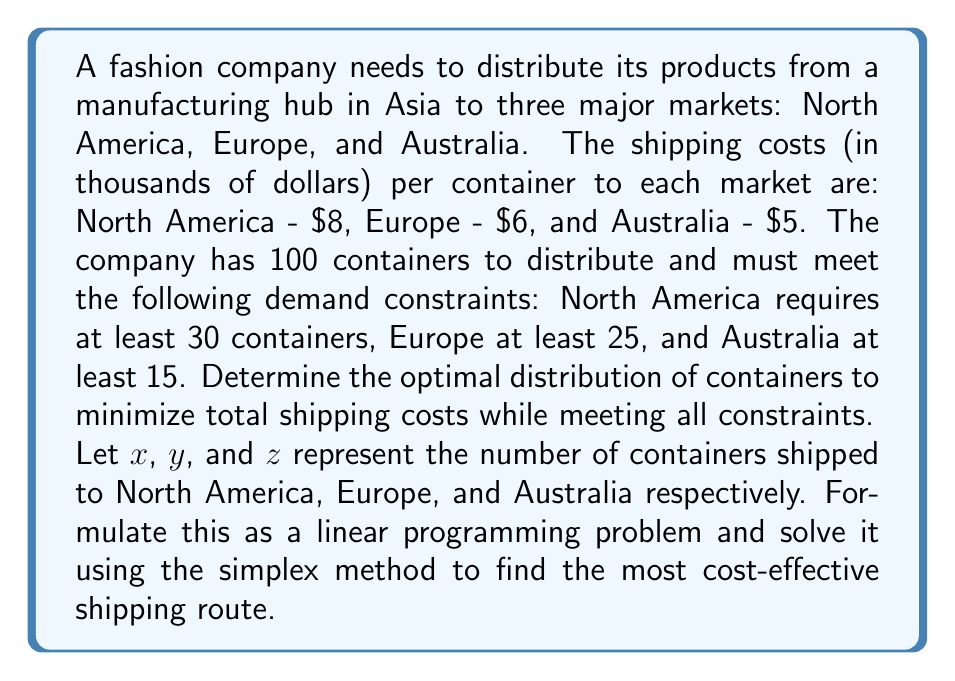Could you help me with this problem? 1. Formulate the linear programming problem:

Objective function: Minimize $Z = 8x + 6y + 5z$

Constraints:
$x + y + z = 100$ (total containers)
$x \geq 30$ (North America demand)
$y \geq 25$ (Europe demand)
$z \geq 15$ (Australia demand)
$x, y, z \geq 0$ (non-negativity)

2. Convert to standard form by introducing slack variables:

Minimize $Z = 8x + 6y + 5z + 0s_1 + 0s_2 + 0s_3 + 0s_4$

Subject to:
$x + y + z + s_1 = 100$
$x - s_2 = 30$
$y - s_3 = 25$
$z - s_4 = 15$
$x, y, z, s_1, s_2, s_3, s_4 \geq 0$

3. Set up initial simplex tableau:

$$
\begin{array}{c|cccccccc|c}
 & x & y & z & s_1 & s_2 & s_3 & s_4 & RHS \\
\hline
Z & -8 & -6 & -5 & 0 & 0 & 0 & 0 & 0 \\
s_1 & 1 & 1 & 1 & 1 & 0 & 0 & 0 & 100 \\
x & 1 & 0 & 0 & 0 & -1 & 0 & 0 & 30 \\
y & 0 & 1 & 0 & 0 & 0 & -1 & 0 & 25 \\
z & 0 & 0 & 1 & 0 & 0 & 0 & -1 & 15 \\
\end{array}
$$

4. Perform simplex iterations until optimal solution is reached:

Final tableau:

$$
\begin{array}{c|cccccccc|c}
 & x & y & z & s_1 & s_2 & s_3 & s_4 & RHS \\
\hline
Z & 0 & 0 & 0 & 3 & 8 & 6 & 5 & 610 \\
x & 0 & 0 & 0 & 1 & -1 & 0 & 0 & 30 \\
y & 0 & 1 & 0 & 0 & 0 & -1 & 0 & 25 \\
z & 0 & 0 & 1 & 0 & 0 & 0 & -1 & 15 \\
s_1 & 1 & 0 & 0 & 0 & 2 & 1 & 1 & 30 \\
\end{array}
$$

5. Interpret the results:
$x = 30$ (North America)
$y = 25$ (Europe)
$z = 15$ (Australia)
$s_1 = 30$ (unused containers)

The minimum total cost is $610,000.
Answer: North America: 30, Europe: 25, Australia: 15, Total cost: $610,000 